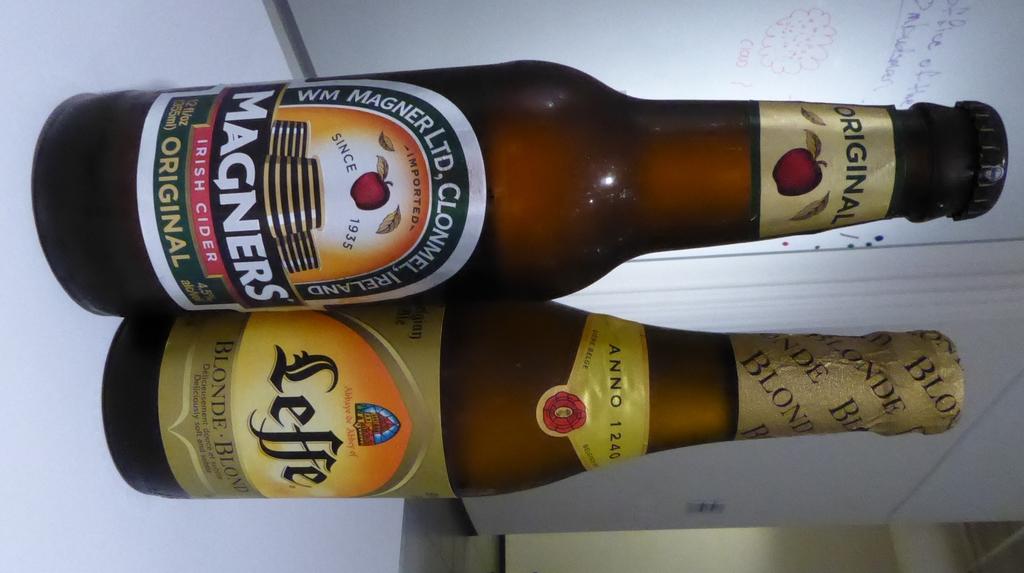In what year did the company begin?
Keep it short and to the point. 1935. 